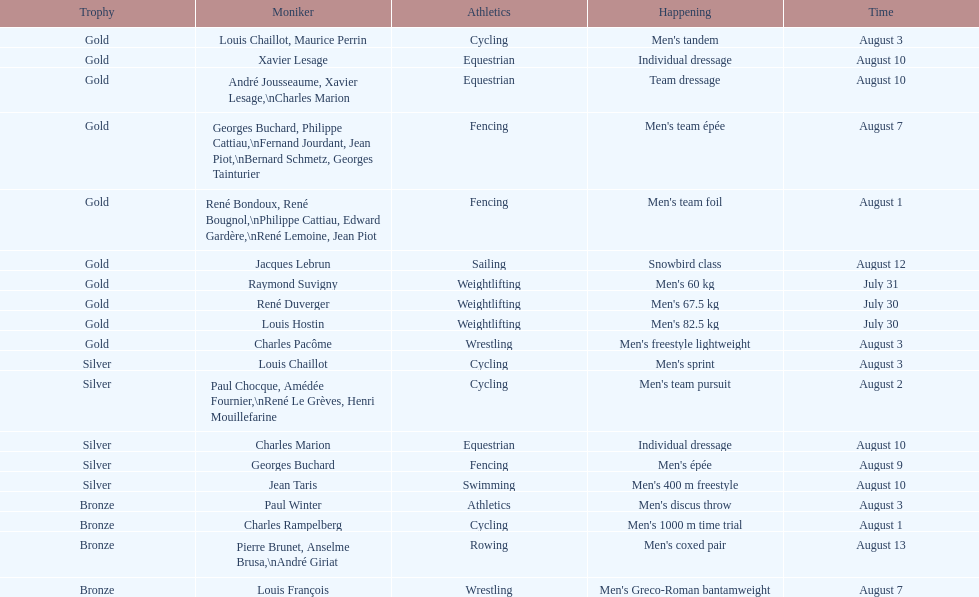How many gold medals did this country win during these olympics? 10. 